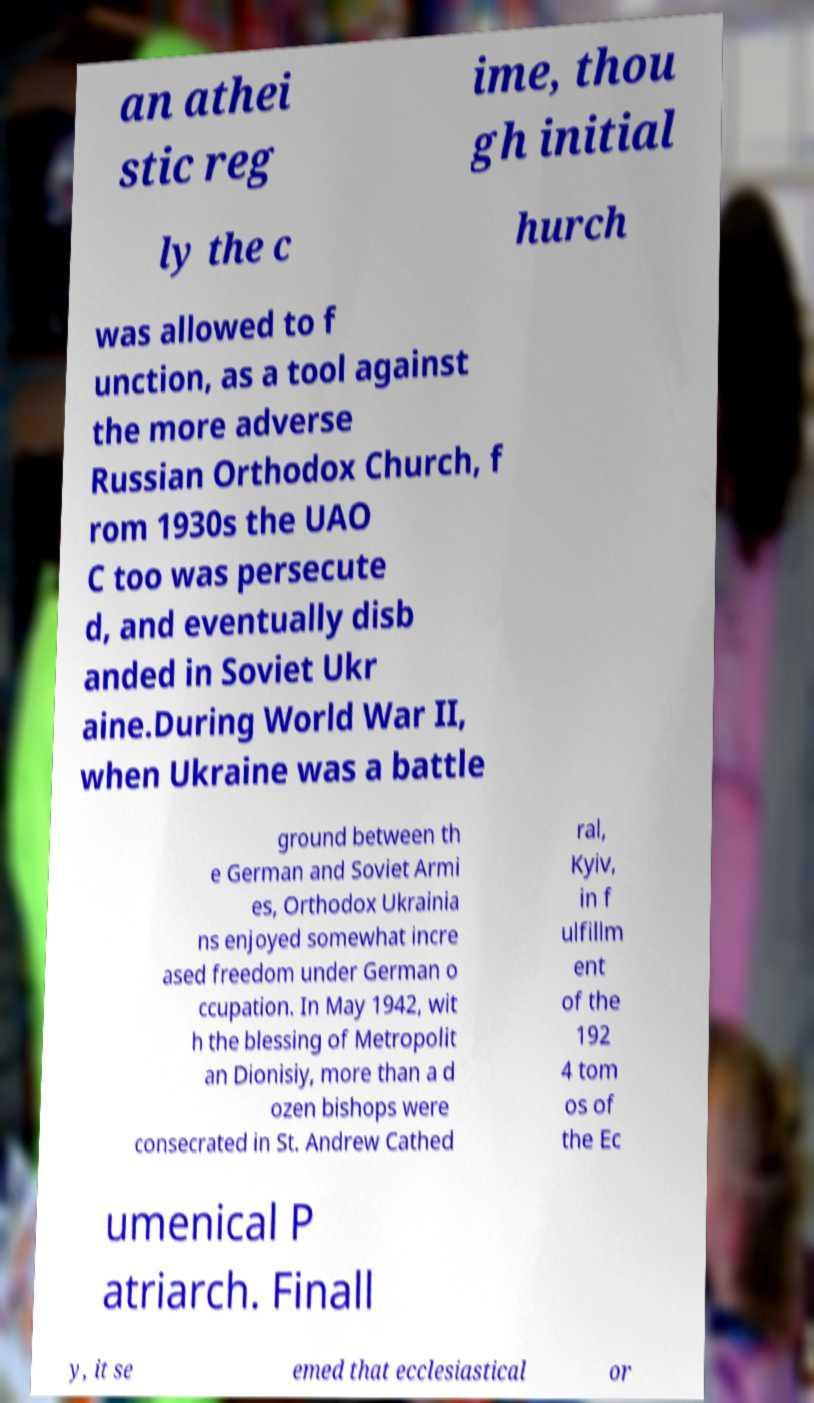There's text embedded in this image that I need extracted. Can you transcribe it verbatim? an athei stic reg ime, thou gh initial ly the c hurch was allowed to f unction, as a tool against the more adverse Russian Orthodox Church, f rom 1930s the UAO C too was persecute d, and eventually disb anded in Soviet Ukr aine.During World War II, when Ukraine was a battle ground between th e German and Soviet Armi es, Orthodox Ukrainia ns enjoyed somewhat incre ased freedom under German o ccupation. In May 1942, wit h the blessing of Metropolit an Dionisiy, more than a d ozen bishops were consecrated in St. Andrew Cathed ral, Kyiv, in f ulfillm ent of the 192 4 tom os of the Ec umenical P atriarch. Finall y, it se emed that ecclesiastical or 